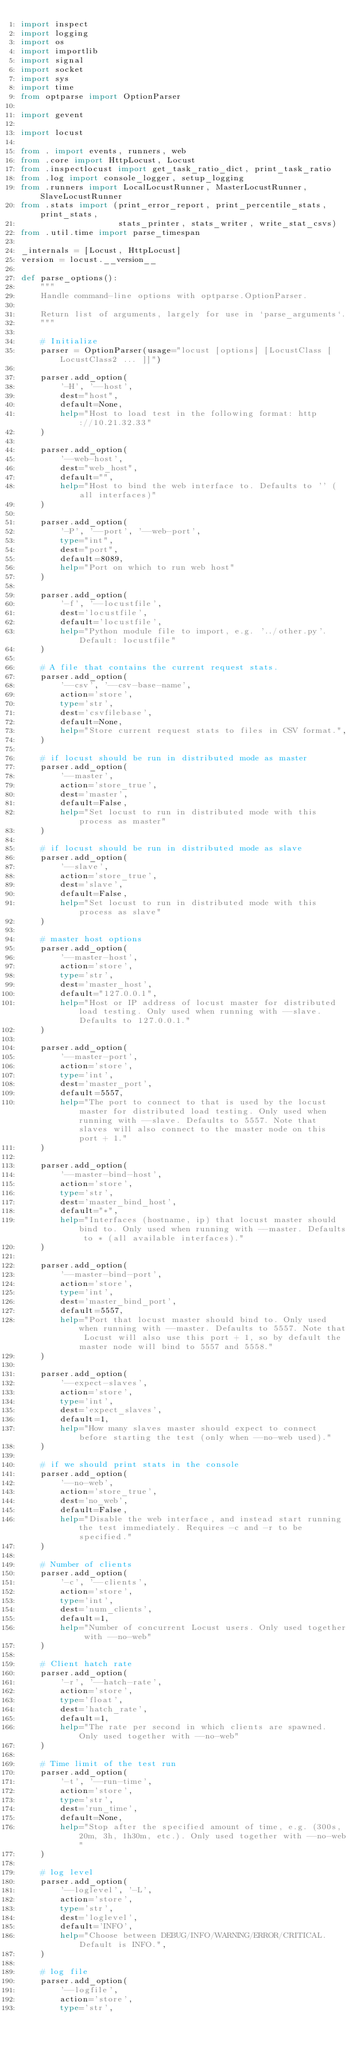<code> <loc_0><loc_0><loc_500><loc_500><_Python_>import inspect
import logging
import os
import importlib
import signal
import socket
import sys
import time
from optparse import OptionParser

import gevent

import locust

from . import events, runners, web
from .core import HttpLocust, Locust
from .inspectlocust import get_task_ratio_dict, print_task_ratio
from .log import console_logger, setup_logging
from .runners import LocalLocustRunner, MasterLocustRunner, SlaveLocustRunner
from .stats import (print_error_report, print_percentile_stats, print_stats,
                    stats_printer, stats_writer, write_stat_csvs)
from .util.time import parse_timespan

_internals = [Locust, HttpLocust]
version = locust.__version__

def parse_options():
    """
    Handle command-line options with optparse.OptionParser.

    Return list of arguments, largely for use in `parse_arguments`.
    """

    # Initialize
    parser = OptionParser(usage="locust [options] [LocustClass [LocustClass2 ... ]]")

    parser.add_option(
        '-H', '--host',
        dest="host",
        default=None,
        help="Host to load test in the following format: http://10.21.32.33"
    )

    parser.add_option(
        '--web-host',
        dest="web_host",
        default="",
        help="Host to bind the web interface to. Defaults to '' (all interfaces)"
    )
    
    parser.add_option(
        '-P', '--port', '--web-port',
        type="int",
        dest="port",
        default=8089,
        help="Port on which to run web host"
    )
    
    parser.add_option(
        '-f', '--locustfile',
        dest='locustfile',
        default='locustfile',
        help="Python module file to import, e.g. '../other.py'. Default: locustfile"
    )

    # A file that contains the current request stats.
    parser.add_option(
        '--csv', '--csv-base-name',
        action='store',
        type='str',
        dest='csvfilebase',
        default=None,
        help="Store current request stats to files in CSV format.",
    )

    # if locust should be run in distributed mode as master
    parser.add_option(
        '--master',
        action='store_true',
        dest='master',
        default=False,
        help="Set locust to run in distributed mode with this process as master"
    )

    # if locust should be run in distributed mode as slave
    parser.add_option(
        '--slave',
        action='store_true',
        dest='slave',
        default=False,
        help="Set locust to run in distributed mode with this process as slave"
    )
    
    # master host options
    parser.add_option(
        '--master-host',
        action='store',
        type='str',
        dest='master_host',
        default="127.0.0.1",
        help="Host or IP address of locust master for distributed load testing. Only used when running with --slave. Defaults to 127.0.0.1."
    )
    
    parser.add_option(
        '--master-port',
        action='store',
        type='int',
        dest='master_port',
        default=5557,
        help="The port to connect to that is used by the locust master for distributed load testing. Only used when running with --slave. Defaults to 5557. Note that slaves will also connect to the master node on this port + 1."
    )

    parser.add_option(
        '--master-bind-host',
        action='store',
        type='str',
        dest='master_bind_host',
        default="*",
        help="Interfaces (hostname, ip) that locust master should bind to. Only used when running with --master. Defaults to * (all available interfaces)."
    )
    
    parser.add_option(
        '--master-bind-port',
        action='store',
        type='int',
        dest='master_bind_port',
        default=5557,
        help="Port that locust master should bind to. Only used when running with --master. Defaults to 5557. Note that Locust will also use this port + 1, so by default the master node will bind to 5557 and 5558."
    )

    parser.add_option(
        '--expect-slaves',
        action='store',
        type='int',
        dest='expect_slaves',
        default=1,
        help="How many slaves master should expect to connect before starting the test (only when --no-web used)."
    )

    # if we should print stats in the console
    parser.add_option(
        '--no-web',
        action='store_true',
        dest='no_web',
        default=False,
        help="Disable the web interface, and instead start running the test immediately. Requires -c and -r to be specified."
    )

    # Number of clients
    parser.add_option(
        '-c', '--clients',
        action='store',
        type='int',
        dest='num_clients',
        default=1,
        help="Number of concurrent Locust users. Only used together with --no-web"
    )

    # Client hatch rate
    parser.add_option(
        '-r', '--hatch-rate',
        action='store',
        type='float',
        dest='hatch_rate',
        default=1,
        help="The rate per second in which clients are spawned. Only used together with --no-web"
    )
    
    # Time limit of the test run
    parser.add_option(
        '-t', '--run-time',
        action='store',
        type='str',
        dest='run_time',
        default=None,
        help="Stop after the specified amount of time, e.g. (300s, 20m, 3h, 1h30m, etc.). Only used together with --no-web"
    )
    
    # log level
    parser.add_option(
        '--loglevel', '-L',
        action='store',
        type='str',
        dest='loglevel',
        default='INFO',
        help="Choose between DEBUG/INFO/WARNING/ERROR/CRITICAL. Default is INFO.",
    )
    
    # log file
    parser.add_option(
        '--logfile',
        action='store',
        type='str',</code> 